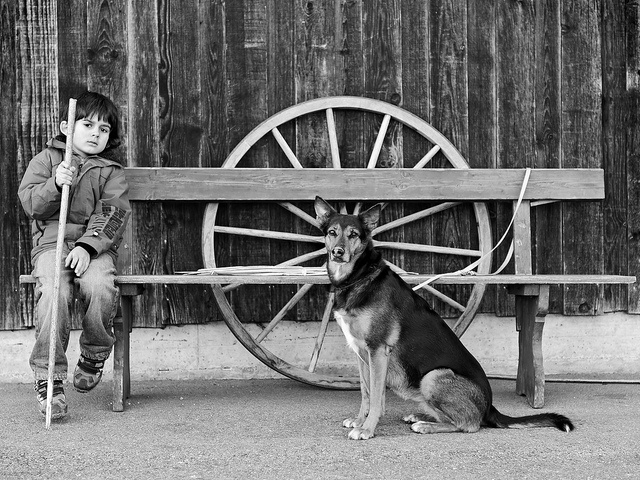Describe the objects in this image and their specific colors. I can see bench in black, darkgray, gray, and lightgray tones, people in black, darkgray, gray, and lightgray tones, and dog in black, gray, darkgray, and lightgray tones in this image. 